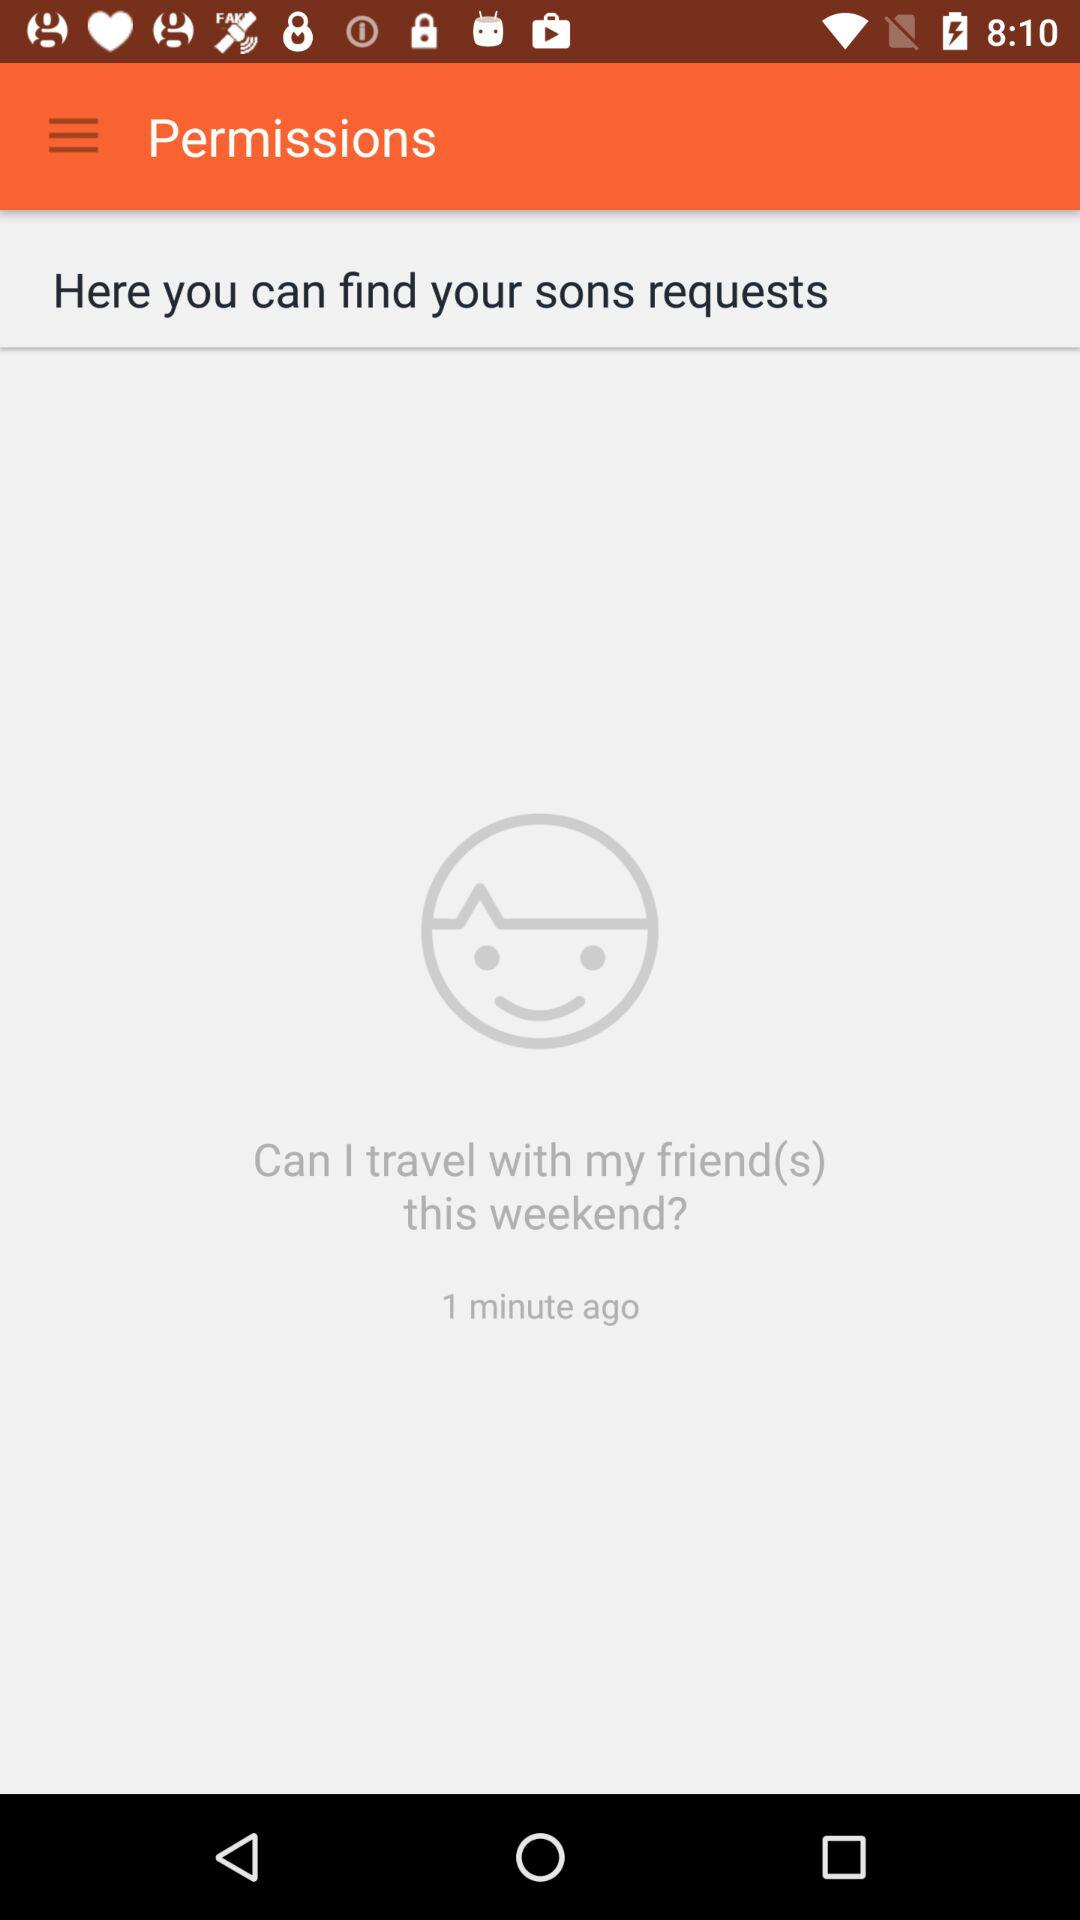How many minutes ago was the request made?
Answer the question using a single word or phrase. 1 